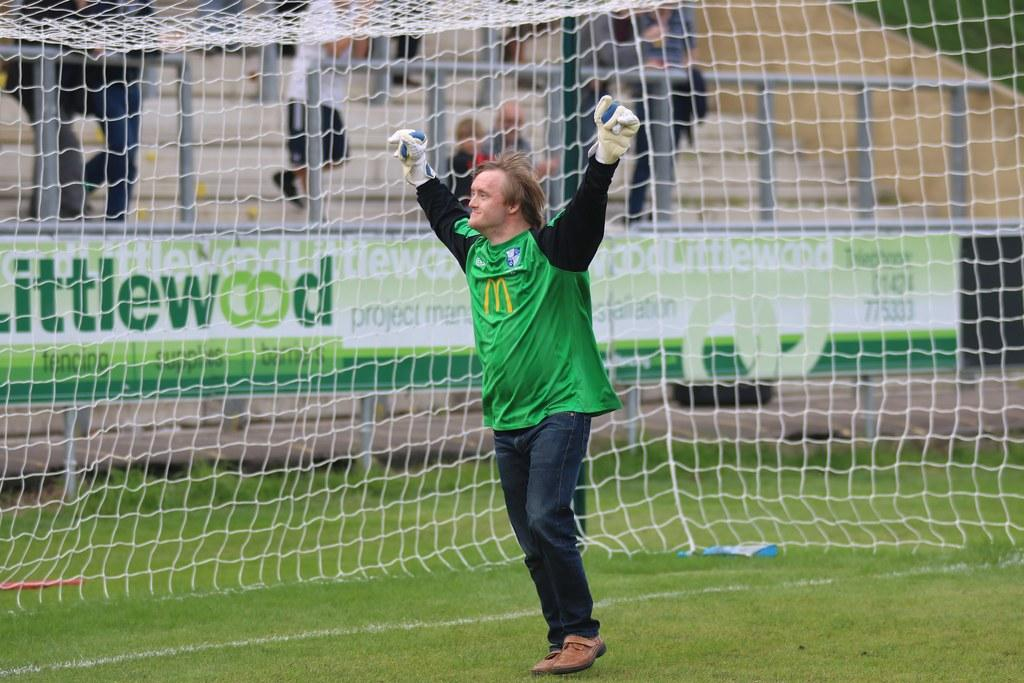<image>
Offer a succinct explanation of the picture presented. A goalkeeper has his arms raised infront of a littlewood sign 